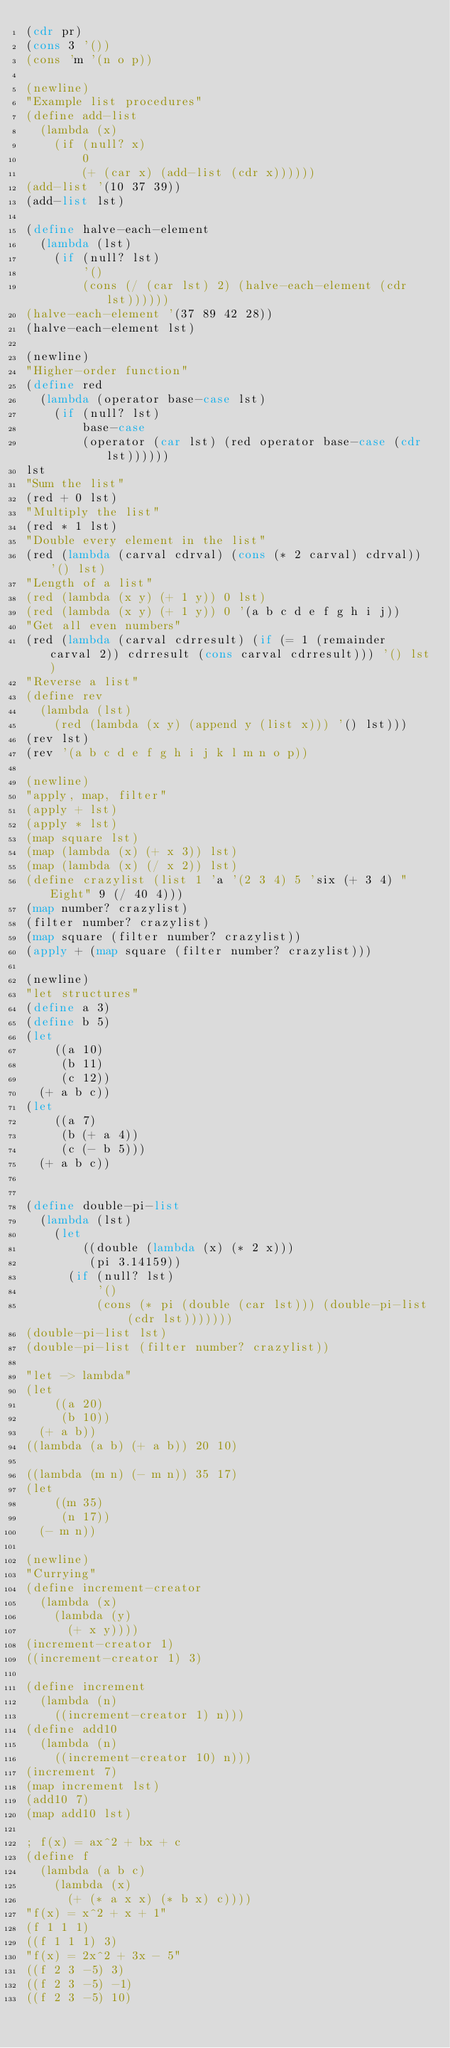Convert code to text. <code><loc_0><loc_0><loc_500><loc_500><_Scheme_>(cdr pr)
(cons 3 '())
(cons 'm '(n o p))

(newline)
"Example list procedures"
(define add-list
  (lambda (x)
    (if (null? x)
        0
        (+ (car x) (add-list (cdr x))))))
(add-list '(10 37 39))
(add-list lst)

(define halve-each-element
  (lambda (lst)
    (if (null? lst)
        '()
        (cons (/ (car lst) 2) (halve-each-element (cdr lst))))))
(halve-each-element '(37 89 42 28))
(halve-each-element lst)

(newline)
"Higher-order function"
(define red
  (lambda (operator base-case lst)
    (if (null? lst)
        base-case
        (operator (car lst) (red operator base-case (cdr lst))))))
lst
"Sum the list"
(red + 0 lst)
"Multiply the list"
(red * 1 lst)
"Double every element in the list"
(red (lambda (carval cdrval) (cons (* 2 carval) cdrval)) '() lst)
"Length of a list"
(red (lambda (x y) (+ 1 y)) 0 lst)
(red (lambda (x y) (+ 1 y)) 0 '(a b c d e f g h i j))
"Get all even numbers"
(red (lambda (carval cdrresult) (if (= 1 (remainder carval 2)) cdrresult (cons carval cdrresult))) '() lst)
"Reverse a list"
(define rev
  (lambda (lst)
    (red (lambda (x y) (append y (list x))) '() lst)))
(rev lst)
(rev '(a b c d e f g h i j k l m n o p))

(newline)
"apply, map, filter"
(apply + lst)
(apply * lst)
(map square lst)
(map (lambda (x) (+ x 3)) lst)
(map (lambda (x) (/ x 2)) lst)
(define crazylist (list 1 'a '(2 3 4) 5 'six (+ 3 4) "Eight" 9 (/ 40 4)))
(map number? crazylist)
(filter number? crazylist)
(map square (filter number? crazylist))
(apply + (map square (filter number? crazylist)))

(newline)
"let structures"
(define a 3)
(define b 5)
(let
    ((a 10)
     (b 11)
     (c 12))
  (+ a b c))
(let
    ((a 7)
     (b (+ a 4))
     (c (- b 5)))
  (+ a b c))


(define double-pi-list
  (lambda (lst)
    (let
        ((double (lambda (x) (* 2 x)))
         (pi 3.14159))
      (if (null? lst)
          '()
          (cons (* pi (double (car lst))) (double-pi-list (cdr lst)))))))
(double-pi-list lst)
(double-pi-list (filter number? crazylist))

"let -> lambda"
(let
    ((a 20)
     (b 10))
  (+ a b))
((lambda (a b) (+ a b)) 20 10)

((lambda (m n) (- m n)) 35 17)
(let
    ((m 35)
     (n 17))
  (- m n))

(newline)
"Currying"
(define increment-creator
  (lambda (x)
    (lambda (y)
      (+ x y))))
(increment-creator 1)
((increment-creator 1) 3)

(define increment
  (lambda (n)
    ((increment-creator 1) n)))
(define add10
  (lambda (n)
    ((increment-creator 10) n)))
(increment 7)
(map increment lst)
(add10 7)
(map add10 lst)

; f(x) = ax^2 + bx + c
(define f
  (lambda (a b c)
    (lambda (x)
      (+ (* a x x) (* b x) c))))
"f(x) = x^2 + x + 1"
(f 1 1 1)
((f 1 1 1) 3)
"f(x) = 2x^2 + 3x - 5"
((f 2 3 -5) 3)
((f 2 3 -5) -1)
((f 2 3 -5) 10)

</code> 